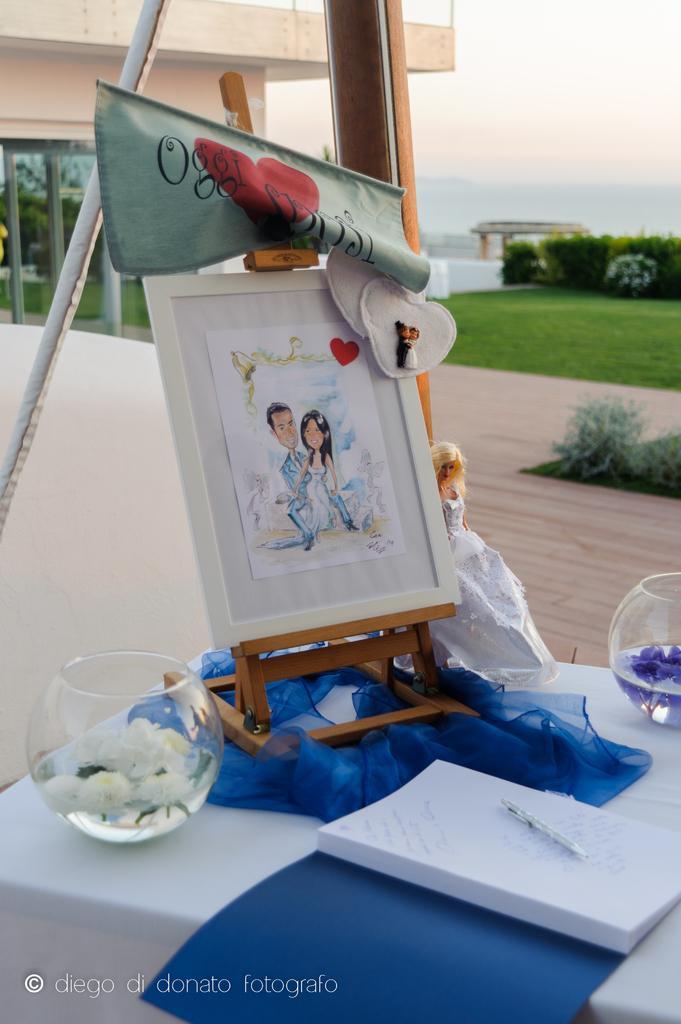How would you summarize this image in a sentence or two? In the center of the image we can see one table. On the table, we can see one cloth, barbie doll, book, pen, wooden stand, photo frame, blue color object, glass containers, loves shape objects, one green color cloth and a few other objects. In the glass containers,we can see water and flowers. At the bottom of the image we can see some text. In the background we can see the sky, clouds, one building, plants, grass and a few other objects. 